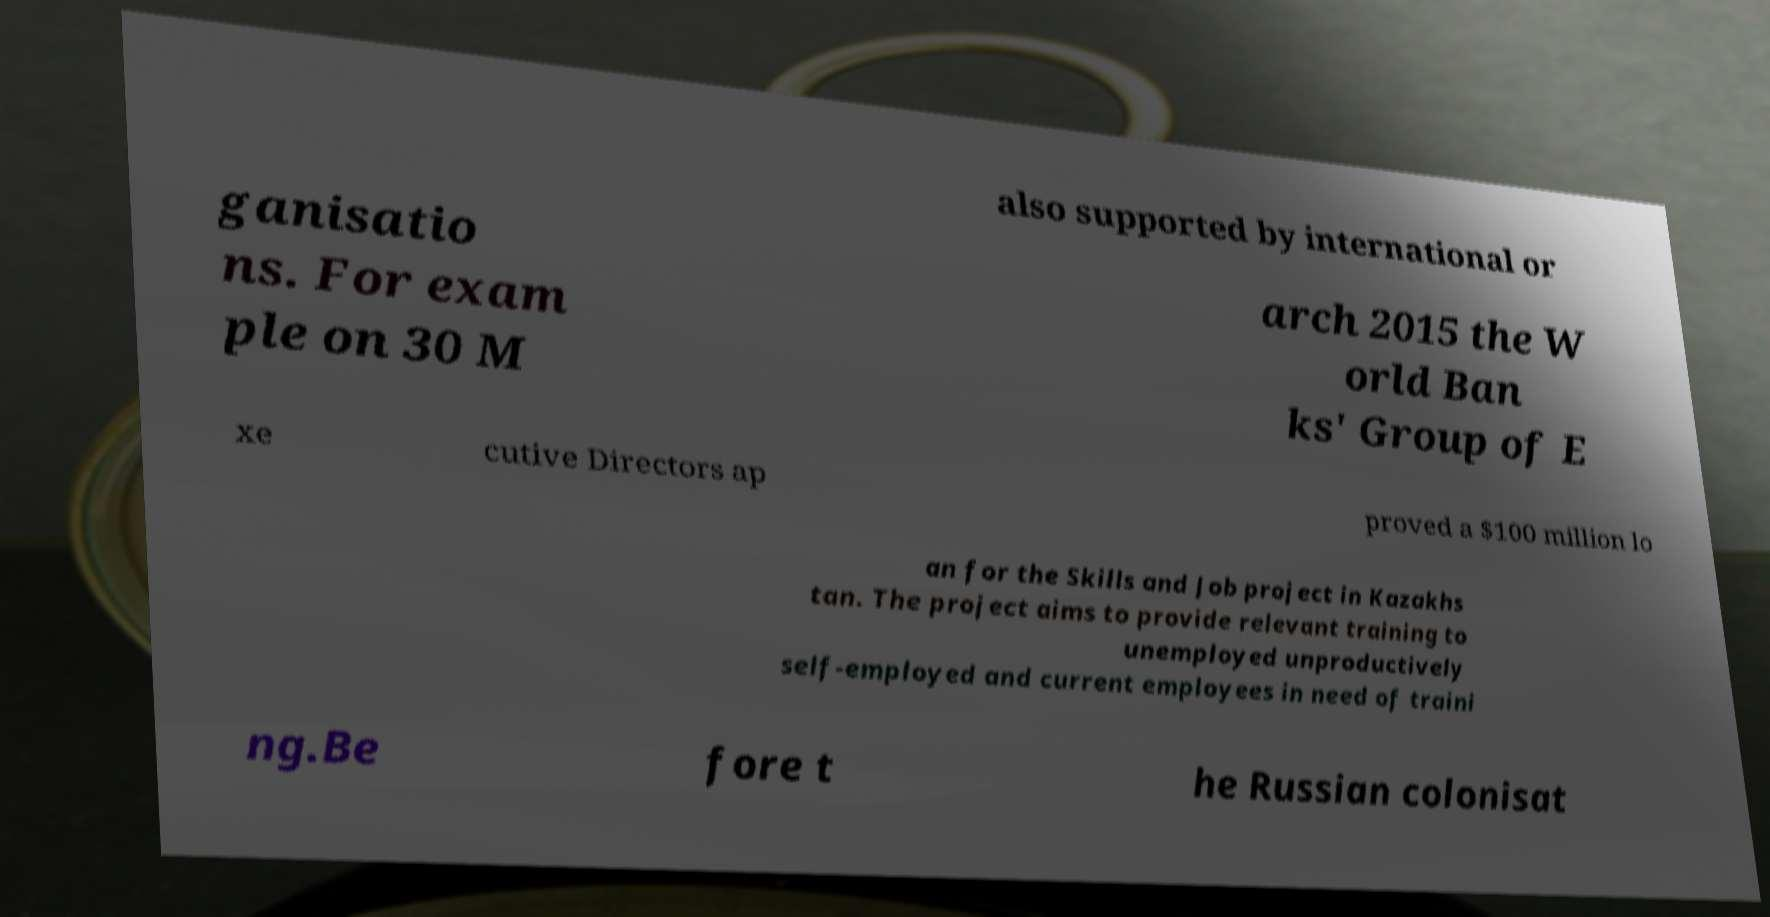What messages or text are displayed in this image? I need them in a readable, typed format. also supported by international or ganisatio ns. For exam ple on 30 M arch 2015 the W orld Ban ks' Group of E xe cutive Directors ap proved a $100 million lo an for the Skills and Job project in Kazakhs tan. The project aims to provide relevant training to unemployed unproductively self-employed and current employees in need of traini ng.Be fore t he Russian colonisat 